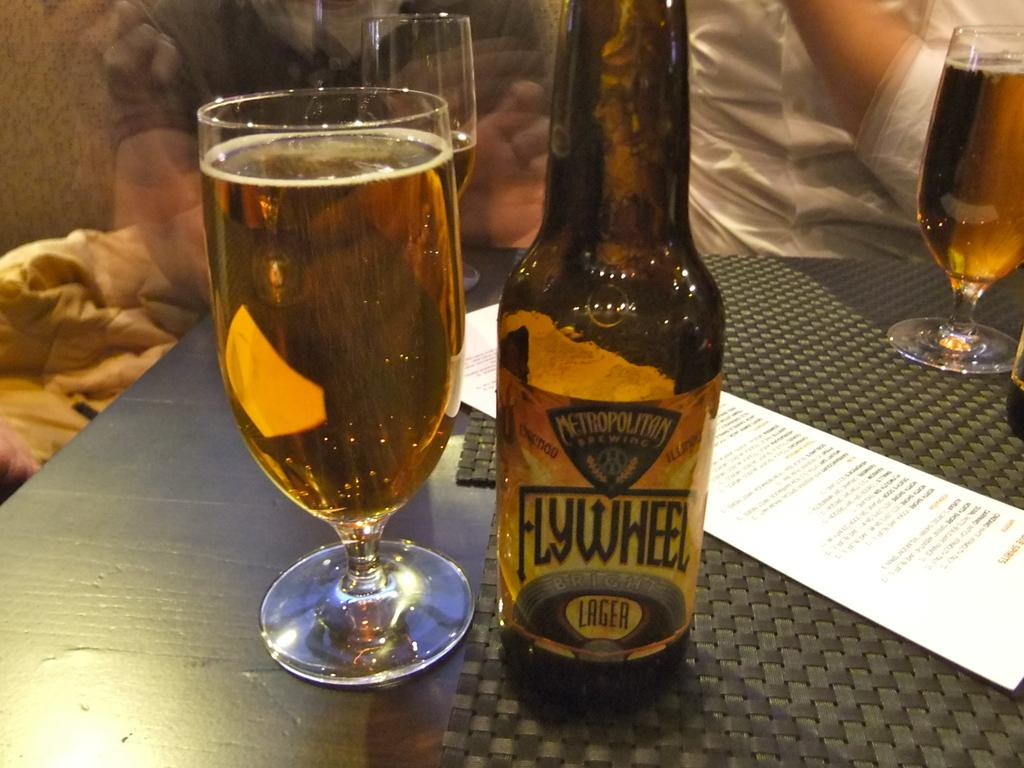<image>
Relay a brief, clear account of the picture shown. A bottle of beer with the words FlyWheel Brewing Written across the label. 